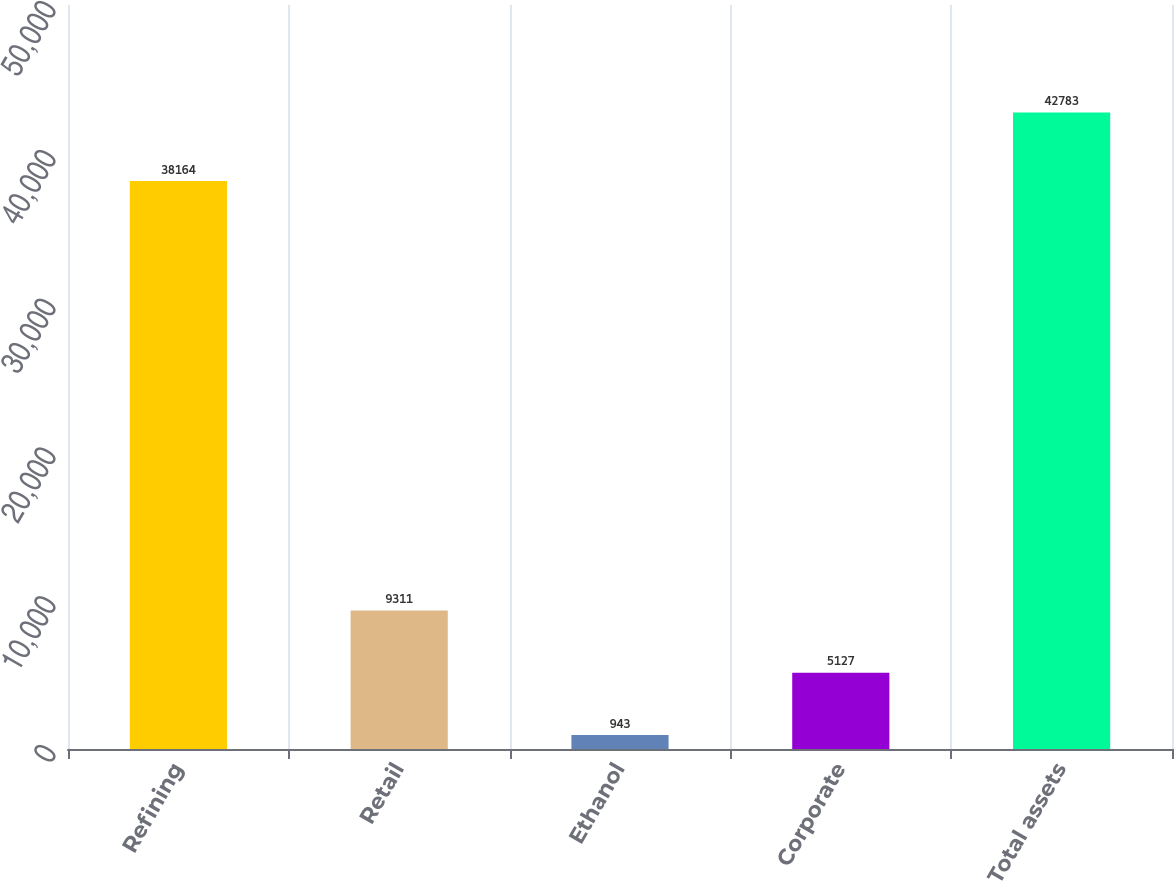<chart> <loc_0><loc_0><loc_500><loc_500><bar_chart><fcel>Refining<fcel>Retail<fcel>Ethanol<fcel>Corporate<fcel>Total assets<nl><fcel>38164<fcel>9311<fcel>943<fcel>5127<fcel>42783<nl></chart> 